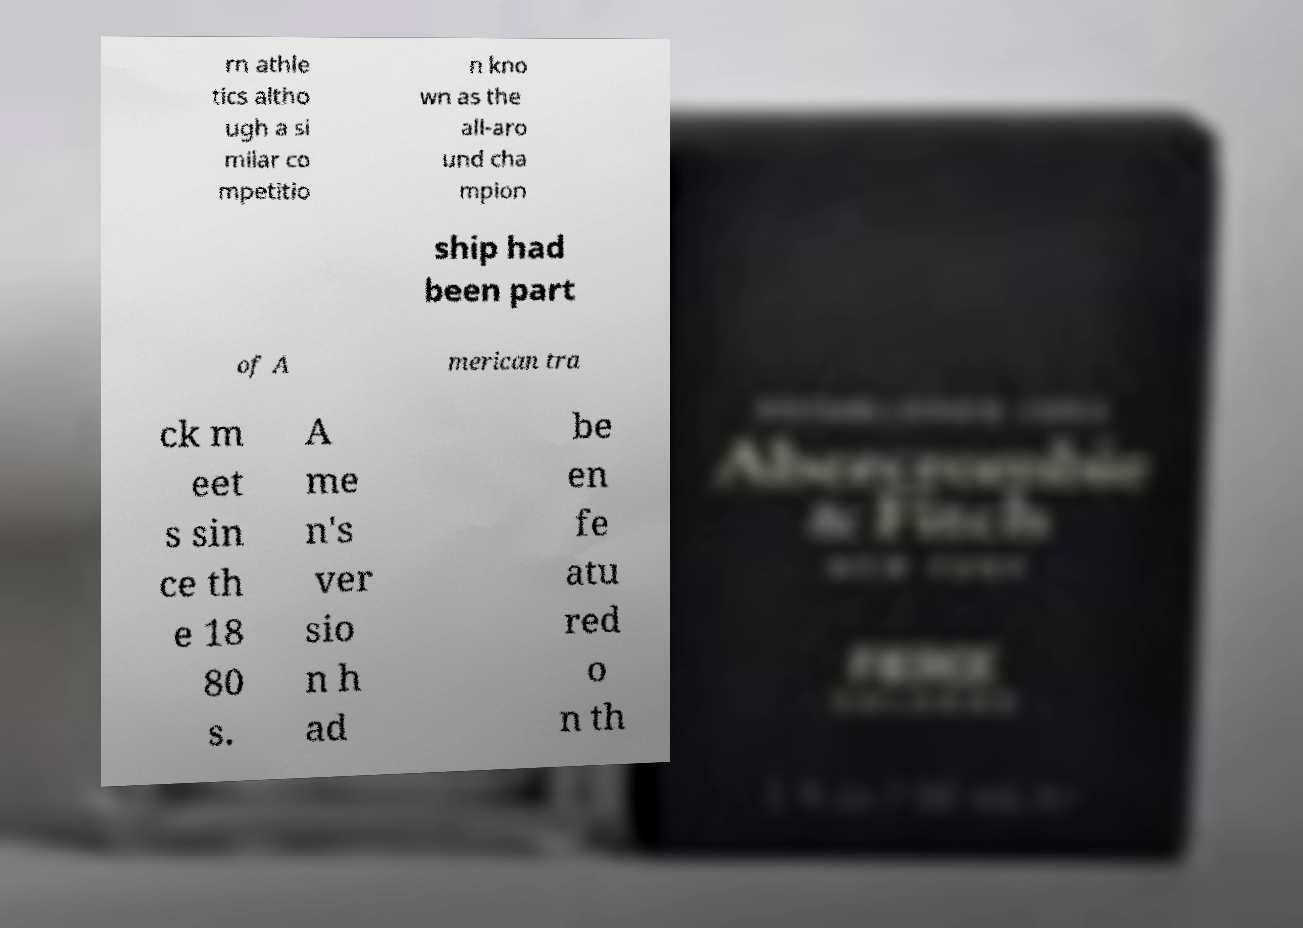What messages or text are displayed in this image? I need them in a readable, typed format. The image displays partially visible text. From what is readable, it mentions: 'rn athle tics altho ugh a si milar co mpetitio n kno wn as the all-aro und cha mpion ship had been part of American tra ck m eet s sin ce th e 18 80 s. A me n's ver sio n h ad be en fe atu red o n th' 